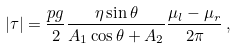<formula> <loc_0><loc_0><loc_500><loc_500>\left | \tau \right | = \frac { p g } { 2 } \frac { \eta \sin \theta } { A _ { 1 } \cos \theta + A _ { 2 } } \frac { \mu _ { l } - \mu _ { r } } { 2 \pi } \, ,</formula> 